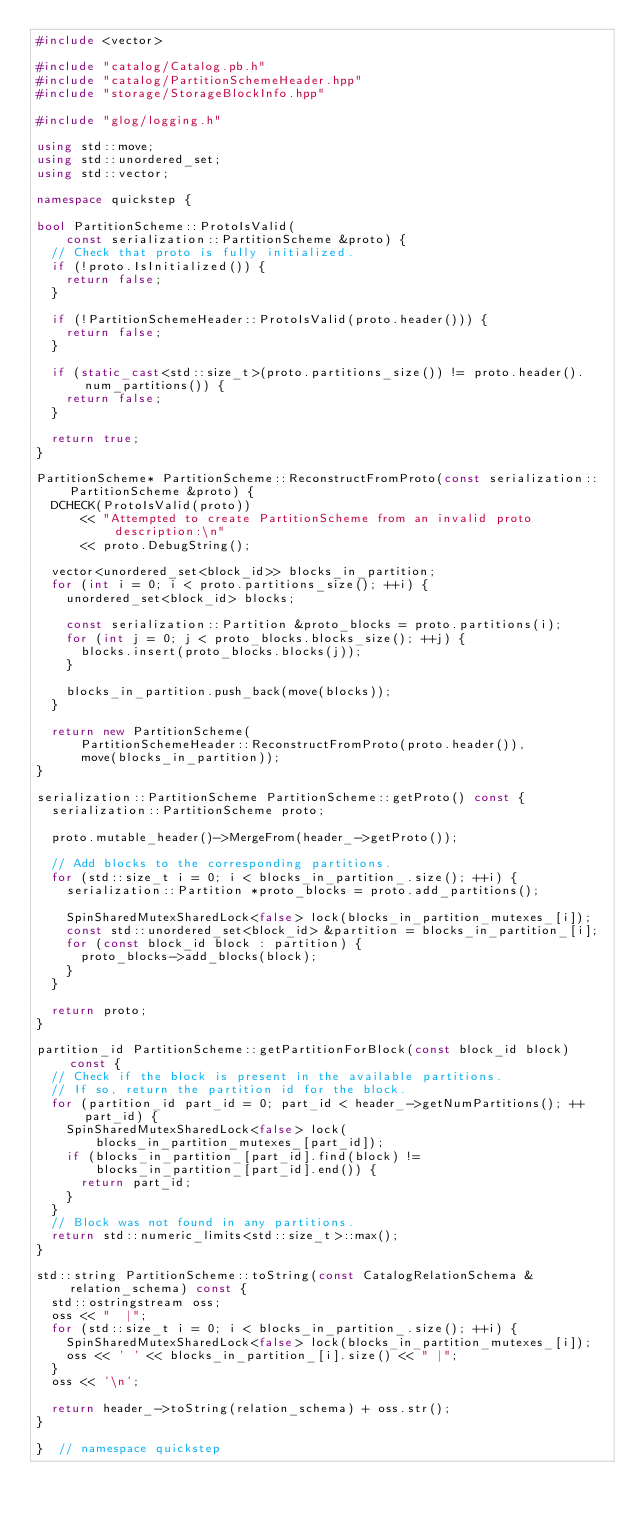Convert code to text. <code><loc_0><loc_0><loc_500><loc_500><_C++_>#include <vector>

#include "catalog/Catalog.pb.h"
#include "catalog/PartitionSchemeHeader.hpp"
#include "storage/StorageBlockInfo.hpp"

#include "glog/logging.h"

using std::move;
using std::unordered_set;
using std::vector;

namespace quickstep {

bool PartitionScheme::ProtoIsValid(
    const serialization::PartitionScheme &proto) {
  // Check that proto is fully initialized.
  if (!proto.IsInitialized()) {
    return false;
  }

  if (!PartitionSchemeHeader::ProtoIsValid(proto.header())) {
    return false;
  }

  if (static_cast<std::size_t>(proto.partitions_size()) != proto.header().num_partitions()) {
    return false;
  }

  return true;
}

PartitionScheme* PartitionScheme::ReconstructFromProto(const serialization::PartitionScheme &proto) {
  DCHECK(ProtoIsValid(proto))
      << "Attempted to create PartitionScheme from an invalid proto description:\n"
      << proto.DebugString();

  vector<unordered_set<block_id>> blocks_in_partition;
  for (int i = 0; i < proto.partitions_size(); ++i) {
    unordered_set<block_id> blocks;

    const serialization::Partition &proto_blocks = proto.partitions(i);
    for (int j = 0; j < proto_blocks.blocks_size(); ++j) {
      blocks.insert(proto_blocks.blocks(j));
    }

    blocks_in_partition.push_back(move(blocks));
  }

  return new PartitionScheme(
      PartitionSchemeHeader::ReconstructFromProto(proto.header()),
      move(blocks_in_partition));
}

serialization::PartitionScheme PartitionScheme::getProto() const {
  serialization::PartitionScheme proto;

  proto.mutable_header()->MergeFrom(header_->getProto());

  // Add blocks to the corresponding partitions.
  for (std::size_t i = 0; i < blocks_in_partition_.size(); ++i) {
    serialization::Partition *proto_blocks = proto.add_partitions();

    SpinSharedMutexSharedLock<false> lock(blocks_in_partition_mutexes_[i]);
    const std::unordered_set<block_id> &partition = blocks_in_partition_[i];
    for (const block_id block : partition) {
      proto_blocks->add_blocks(block);
    }
  }

  return proto;
}

partition_id PartitionScheme::getPartitionForBlock(const block_id block) const {
  // Check if the block is present in the available partitions.
  // If so, return the partition id for the block.
  for (partition_id part_id = 0; part_id < header_->getNumPartitions(); ++part_id) {
    SpinSharedMutexSharedLock<false> lock(
        blocks_in_partition_mutexes_[part_id]);
    if (blocks_in_partition_[part_id].find(block) !=
        blocks_in_partition_[part_id].end()) {
      return part_id;
    }
  }
  // Block was not found in any partitions.
  return std::numeric_limits<std::size_t>::max();
}

std::string PartitionScheme::toString(const CatalogRelationSchema &relation_schema) const {
  std::ostringstream oss;
  oss << "  |";
  for (std::size_t i = 0; i < blocks_in_partition_.size(); ++i) {
    SpinSharedMutexSharedLock<false> lock(blocks_in_partition_mutexes_[i]);
    oss << ' ' << blocks_in_partition_[i].size() << " |";
  }
  oss << '\n';

  return header_->toString(relation_schema) + oss.str();
}

}  // namespace quickstep
</code> 